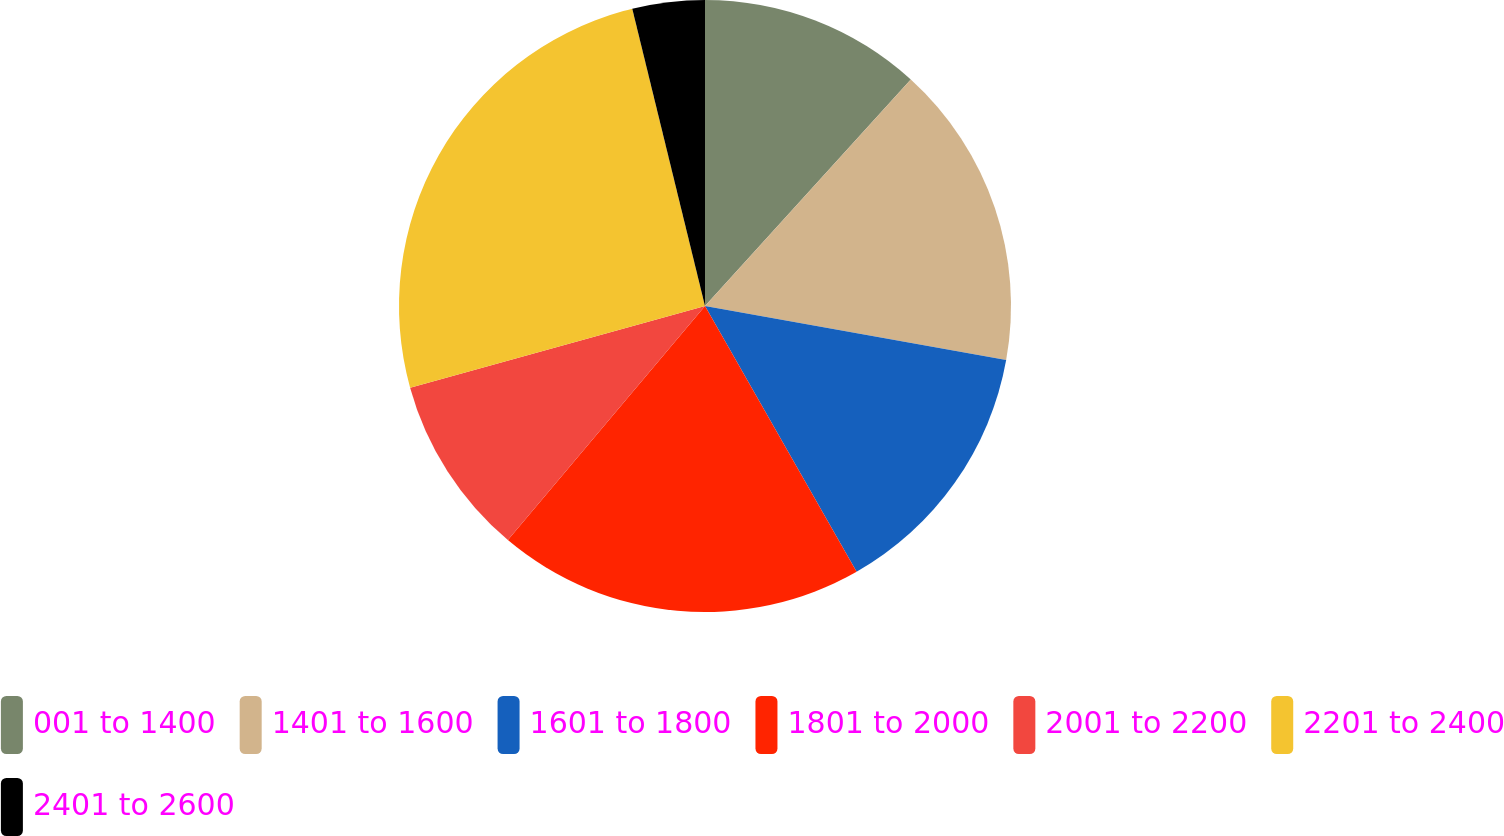Convert chart. <chart><loc_0><loc_0><loc_500><loc_500><pie_chart><fcel>001 to 1400<fcel>1401 to 1600<fcel>1601 to 1800<fcel>1801 to 2000<fcel>2001 to 2200<fcel>2201 to 2400<fcel>2401 to 2600<nl><fcel>11.74%<fcel>16.09%<fcel>13.92%<fcel>19.39%<fcel>9.56%<fcel>25.48%<fcel>3.82%<nl></chart> 